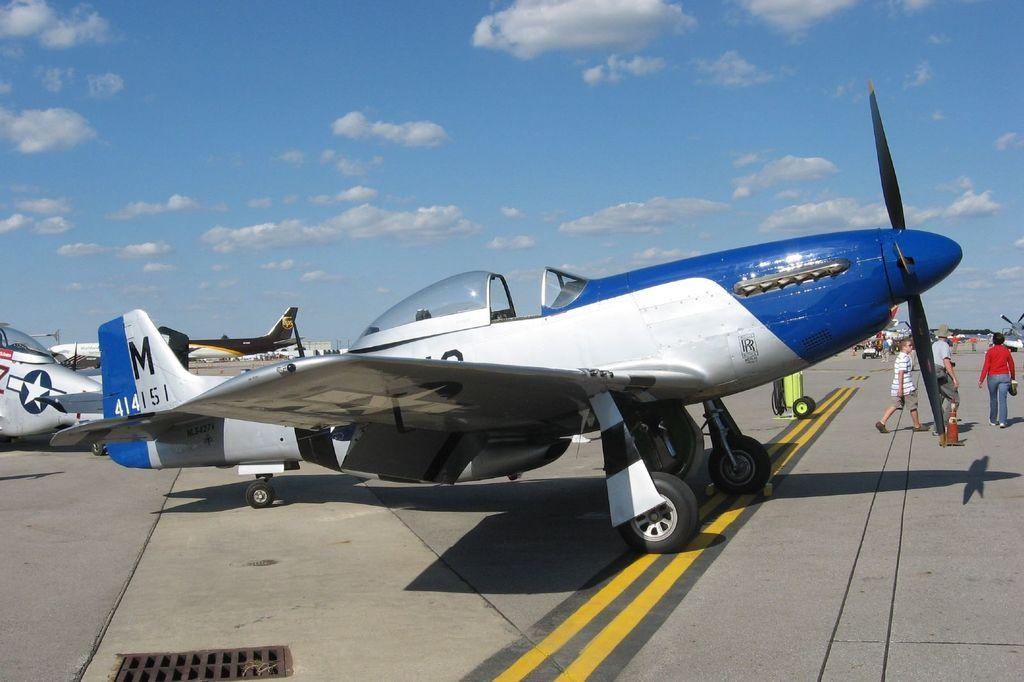<image>
Describe the image concisely. a white and blue airplane that says M 414151 